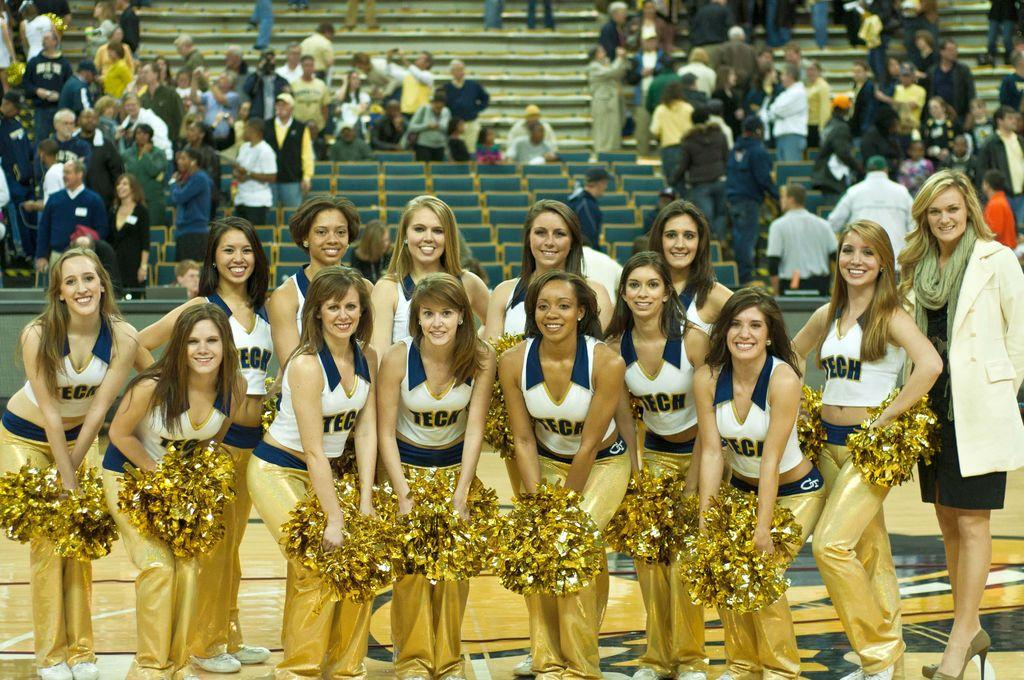<image>
Create a compact narrative representing the image presented. the word Teca is on the white jersey of the girl 